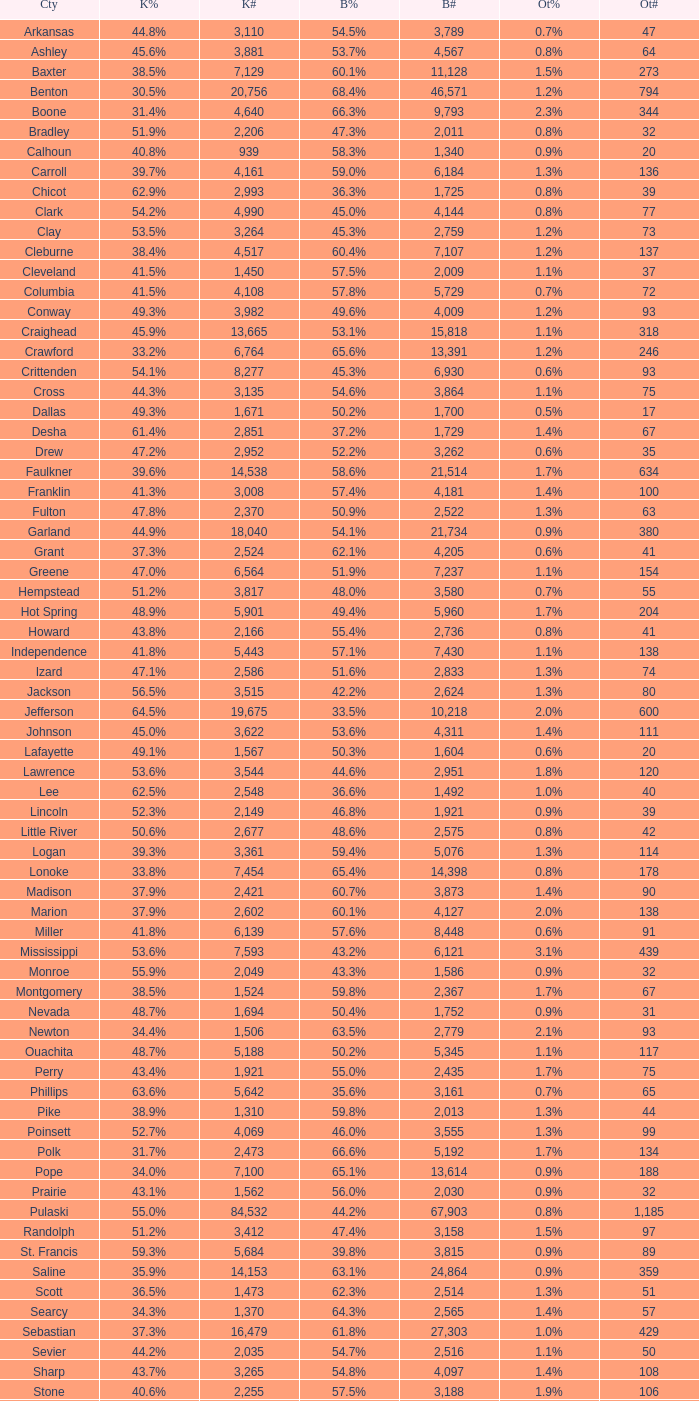Give me the full table as a dictionary. {'header': ['Cty', 'K%', 'K#', 'B%', 'B#', 'Ot%', 'Ot#'], 'rows': [['Arkansas', '44.8%', '3,110', '54.5%', '3,789', '0.7%', '47'], ['Ashley', '45.6%', '3,881', '53.7%', '4,567', '0.8%', '64'], ['Baxter', '38.5%', '7,129', '60.1%', '11,128', '1.5%', '273'], ['Benton', '30.5%', '20,756', '68.4%', '46,571', '1.2%', '794'], ['Boone', '31.4%', '4,640', '66.3%', '9,793', '2.3%', '344'], ['Bradley', '51.9%', '2,206', '47.3%', '2,011', '0.8%', '32'], ['Calhoun', '40.8%', '939', '58.3%', '1,340', '0.9%', '20'], ['Carroll', '39.7%', '4,161', '59.0%', '6,184', '1.3%', '136'], ['Chicot', '62.9%', '2,993', '36.3%', '1,725', '0.8%', '39'], ['Clark', '54.2%', '4,990', '45.0%', '4,144', '0.8%', '77'], ['Clay', '53.5%', '3,264', '45.3%', '2,759', '1.2%', '73'], ['Cleburne', '38.4%', '4,517', '60.4%', '7,107', '1.2%', '137'], ['Cleveland', '41.5%', '1,450', '57.5%', '2,009', '1.1%', '37'], ['Columbia', '41.5%', '4,108', '57.8%', '5,729', '0.7%', '72'], ['Conway', '49.3%', '3,982', '49.6%', '4,009', '1.2%', '93'], ['Craighead', '45.9%', '13,665', '53.1%', '15,818', '1.1%', '318'], ['Crawford', '33.2%', '6,764', '65.6%', '13,391', '1.2%', '246'], ['Crittenden', '54.1%', '8,277', '45.3%', '6,930', '0.6%', '93'], ['Cross', '44.3%', '3,135', '54.6%', '3,864', '1.1%', '75'], ['Dallas', '49.3%', '1,671', '50.2%', '1,700', '0.5%', '17'], ['Desha', '61.4%', '2,851', '37.2%', '1,729', '1.4%', '67'], ['Drew', '47.2%', '2,952', '52.2%', '3,262', '0.6%', '35'], ['Faulkner', '39.6%', '14,538', '58.6%', '21,514', '1.7%', '634'], ['Franklin', '41.3%', '3,008', '57.4%', '4,181', '1.4%', '100'], ['Fulton', '47.8%', '2,370', '50.9%', '2,522', '1.3%', '63'], ['Garland', '44.9%', '18,040', '54.1%', '21,734', '0.9%', '380'], ['Grant', '37.3%', '2,524', '62.1%', '4,205', '0.6%', '41'], ['Greene', '47.0%', '6,564', '51.9%', '7,237', '1.1%', '154'], ['Hempstead', '51.2%', '3,817', '48.0%', '3,580', '0.7%', '55'], ['Hot Spring', '48.9%', '5,901', '49.4%', '5,960', '1.7%', '204'], ['Howard', '43.8%', '2,166', '55.4%', '2,736', '0.8%', '41'], ['Independence', '41.8%', '5,443', '57.1%', '7,430', '1.1%', '138'], ['Izard', '47.1%', '2,586', '51.6%', '2,833', '1.3%', '74'], ['Jackson', '56.5%', '3,515', '42.2%', '2,624', '1.3%', '80'], ['Jefferson', '64.5%', '19,675', '33.5%', '10,218', '2.0%', '600'], ['Johnson', '45.0%', '3,622', '53.6%', '4,311', '1.4%', '111'], ['Lafayette', '49.1%', '1,567', '50.3%', '1,604', '0.6%', '20'], ['Lawrence', '53.6%', '3,544', '44.6%', '2,951', '1.8%', '120'], ['Lee', '62.5%', '2,548', '36.6%', '1,492', '1.0%', '40'], ['Lincoln', '52.3%', '2,149', '46.8%', '1,921', '0.9%', '39'], ['Little River', '50.6%', '2,677', '48.6%', '2,575', '0.8%', '42'], ['Logan', '39.3%', '3,361', '59.4%', '5,076', '1.3%', '114'], ['Lonoke', '33.8%', '7,454', '65.4%', '14,398', '0.8%', '178'], ['Madison', '37.9%', '2,421', '60.7%', '3,873', '1.4%', '90'], ['Marion', '37.9%', '2,602', '60.1%', '4,127', '2.0%', '138'], ['Miller', '41.8%', '6,139', '57.6%', '8,448', '0.6%', '91'], ['Mississippi', '53.6%', '7,593', '43.2%', '6,121', '3.1%', '439'], ['Monroe', '55.9%', '2,049', '43.3%', '1,586', '0.9%', '32'], ['Montgomery', '38.5%', '1,524', '59.8%', '2,367', '1.7%', '67'], ['Nevada', '48.7%', '1,694', '50.4%', '1,752', '0.9%', '31'], ['Newton', '34.4%', '1,506', '63.5%', '2,779', '2.1%', '93'], ['Ouachita', '48.7%', '5,188', '50.2%', '5,345', '1.1%', '117'], ['Perry', '43.4%', '1,921', '55.0%', '2,435', '1.7%', '75'], ['Phillips', '63.6%', '5,642', '35.6%', '3,161', '0.7%', '65'], ['Pike', '38.9%', '1,310', '59.8%', '2,013', '1.3%', '44'], ['Poinsett', '52.7%', '4,069', '46.0%', '3,555', '1.3%', '99'], ['Polk', '31.7%', '2,473', '66.6%', '5,192', '1.7%', '134'], ['Pope', '34.0%', '7,100', '65.1%', '13,614', '0.9%', '188'], ['Prairie', '43.1%', '1,562', '56.0%', '2,030', '0.9%', '32'], ['Pulaski', '55.0%', '84,532', '44.2%', '67,903', '0.8%', '1,185'], ['Randolph', '51.2%', '3,412', '47.4%', '3,158', '1.5%', '97'], ['St. Francis', '59.3%', '5,684', '39.8%', '3,815', '0.9%', '89'], ['Saline', '35.9%', '14,153', '63.1%', '24,864', '0.9%', '359'], ['Scott', '36.5%', '1,473', '62.3%', '2,514', '1.3%', '51'], ['Searcy', '34.3%', '1,370', '64.3%', '2,565', '1.4%', '57'], ['Sebastian', '37.3%', '16,479', '61.8%', '27,303', '1.0%', '429'], ['Sevier', '44.2%', '2,035', '54.7%', '2,516', '1.1%', '50'], ['Sharp', '43.7%', '3,265', '54.8%', '4,097', '1.4%', '108'], ['Stone', '40.6%', '2,255', '57.5%', '3,188', '1.9%', '106'], ['Union', '39.7%', '7,071', '58.9%', '10,502', '1.5%', '259'], ['Van Buren', '44.9%', '3,310', '54.1%', '3,988', '1.0%', '76'], ['Washington', '43.1%', '27,597', '55.7%', '35,726', '1.2%', '780'], ['White', '34.5%', '9,129', '64.3%', '17,001', '1.1%', '295'], ['Woodruff', '65.2%', '1,972', '33.7%', '1,021', '1.1%', '33'], ['Yell', '43.7%', '2,913', '55.2%', '3,678', '1.0%', '68']]} What is the highest Bush#, when Others% is "1.7%", when Others# is less than 75, and when Kerry# is greater than 1,524? None. 